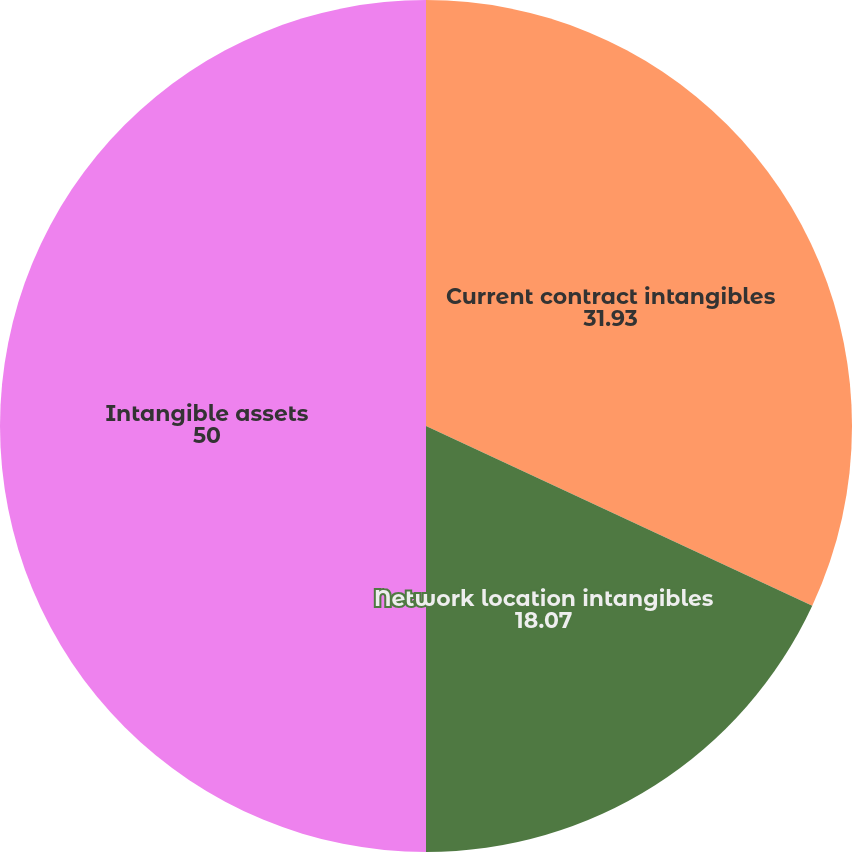<chart> <loc_0><loc_0><loc_500><loc_500><pie_chart><fcel>Current contract intangibles<fcel>Network location intangibles<fcel>Intangible assets<nl><fcel>31.93%<fcel>18.07%<fcel>50.0%<nl></chart> 